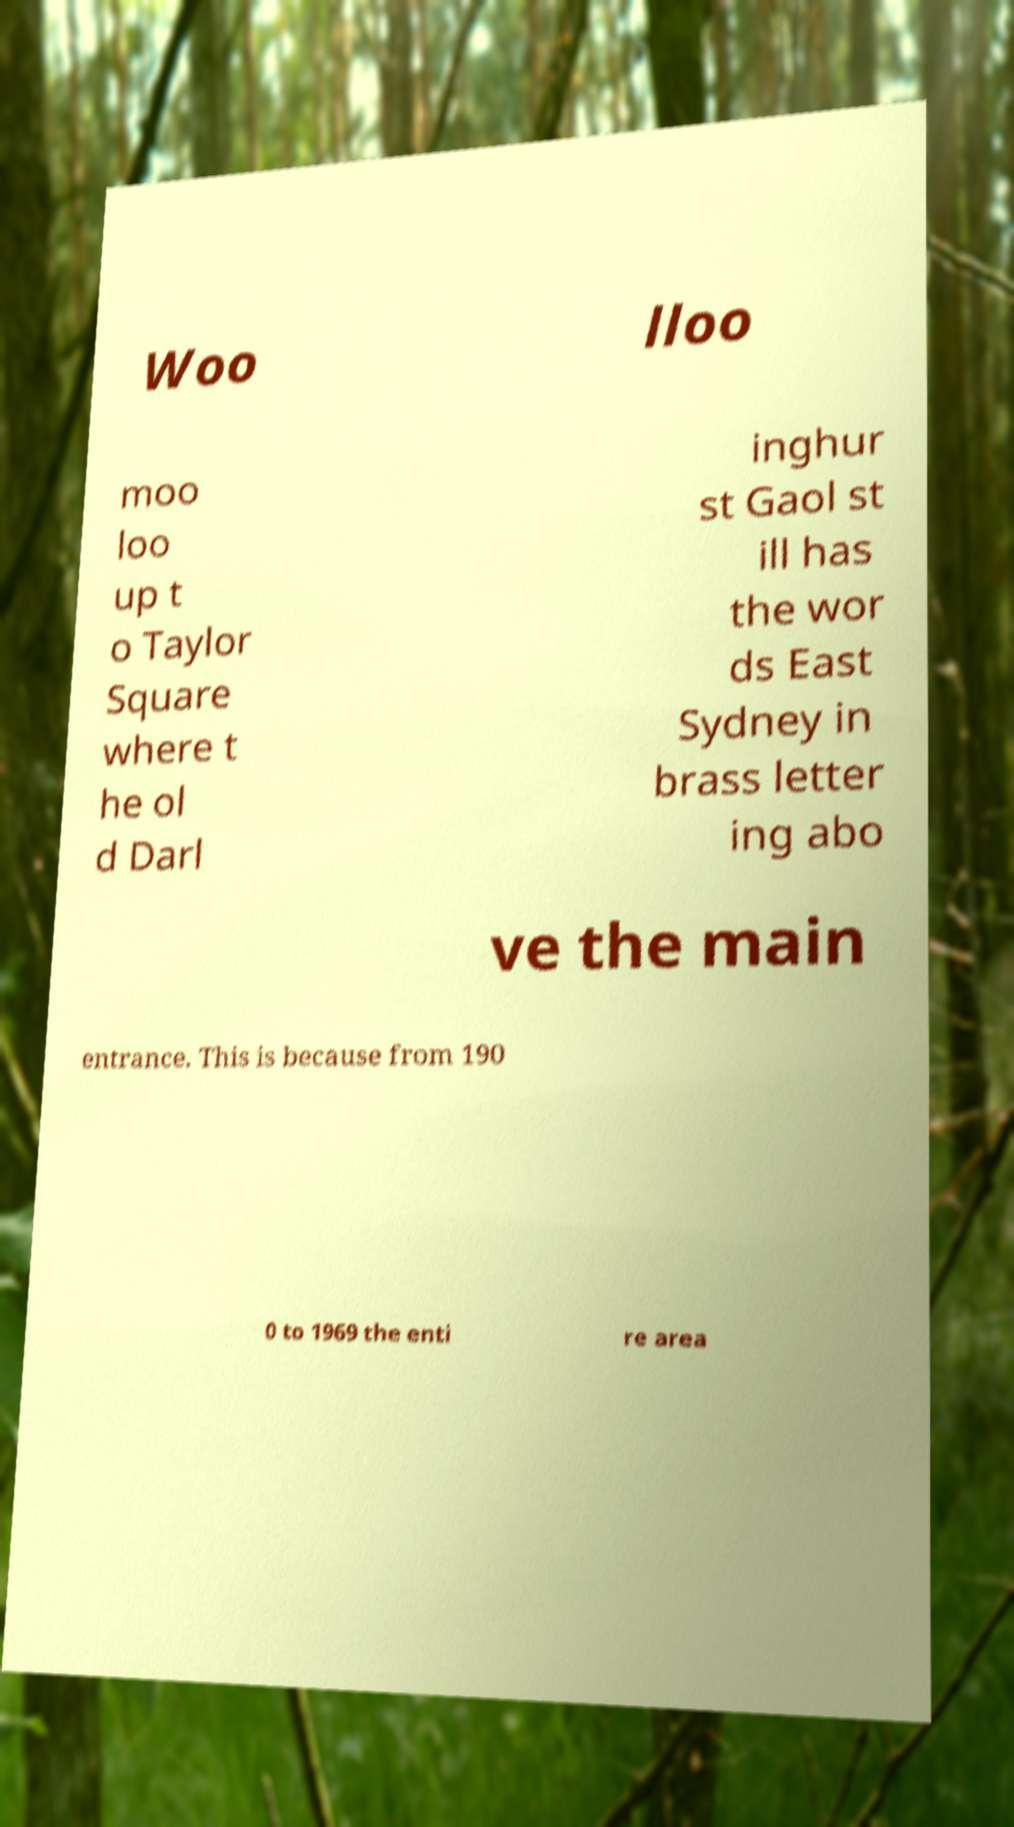I need the written content from this picture converted into text. Can you do that? Woo lloo moo loo up t o Taylor Square where t he ol d Darl inghur st Gaol st ill has the wor ds East Sydney in brass letter ing abo ve the main entrance. This is because from 190 0 to 1969 the enti re area 